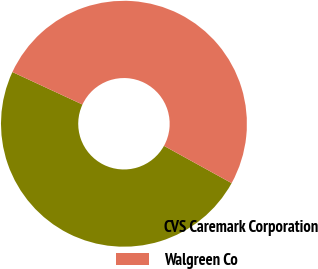Convert chart. <chart><loc_0><loc_0><loc_500><loc_500><pie_chart><fcel>CVS Caremark Corporation<fcel>Walgreen Co<nl><fcel>48.89%<fcel>51.11%<nl></chart> 